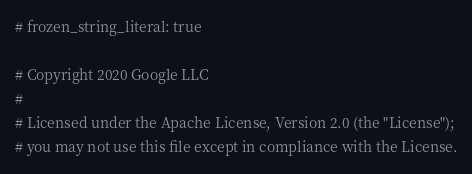Convert code to text. <code><loc_0><loc_0><loc_500><loc_500><_Ruby_># frozen_string_literal: true

# Copyright 2020 Google LLC
#
# Licensed under the Apache License, Version 2.0 (the "License");
# you may not use this file except in compliance with the License.</code> 